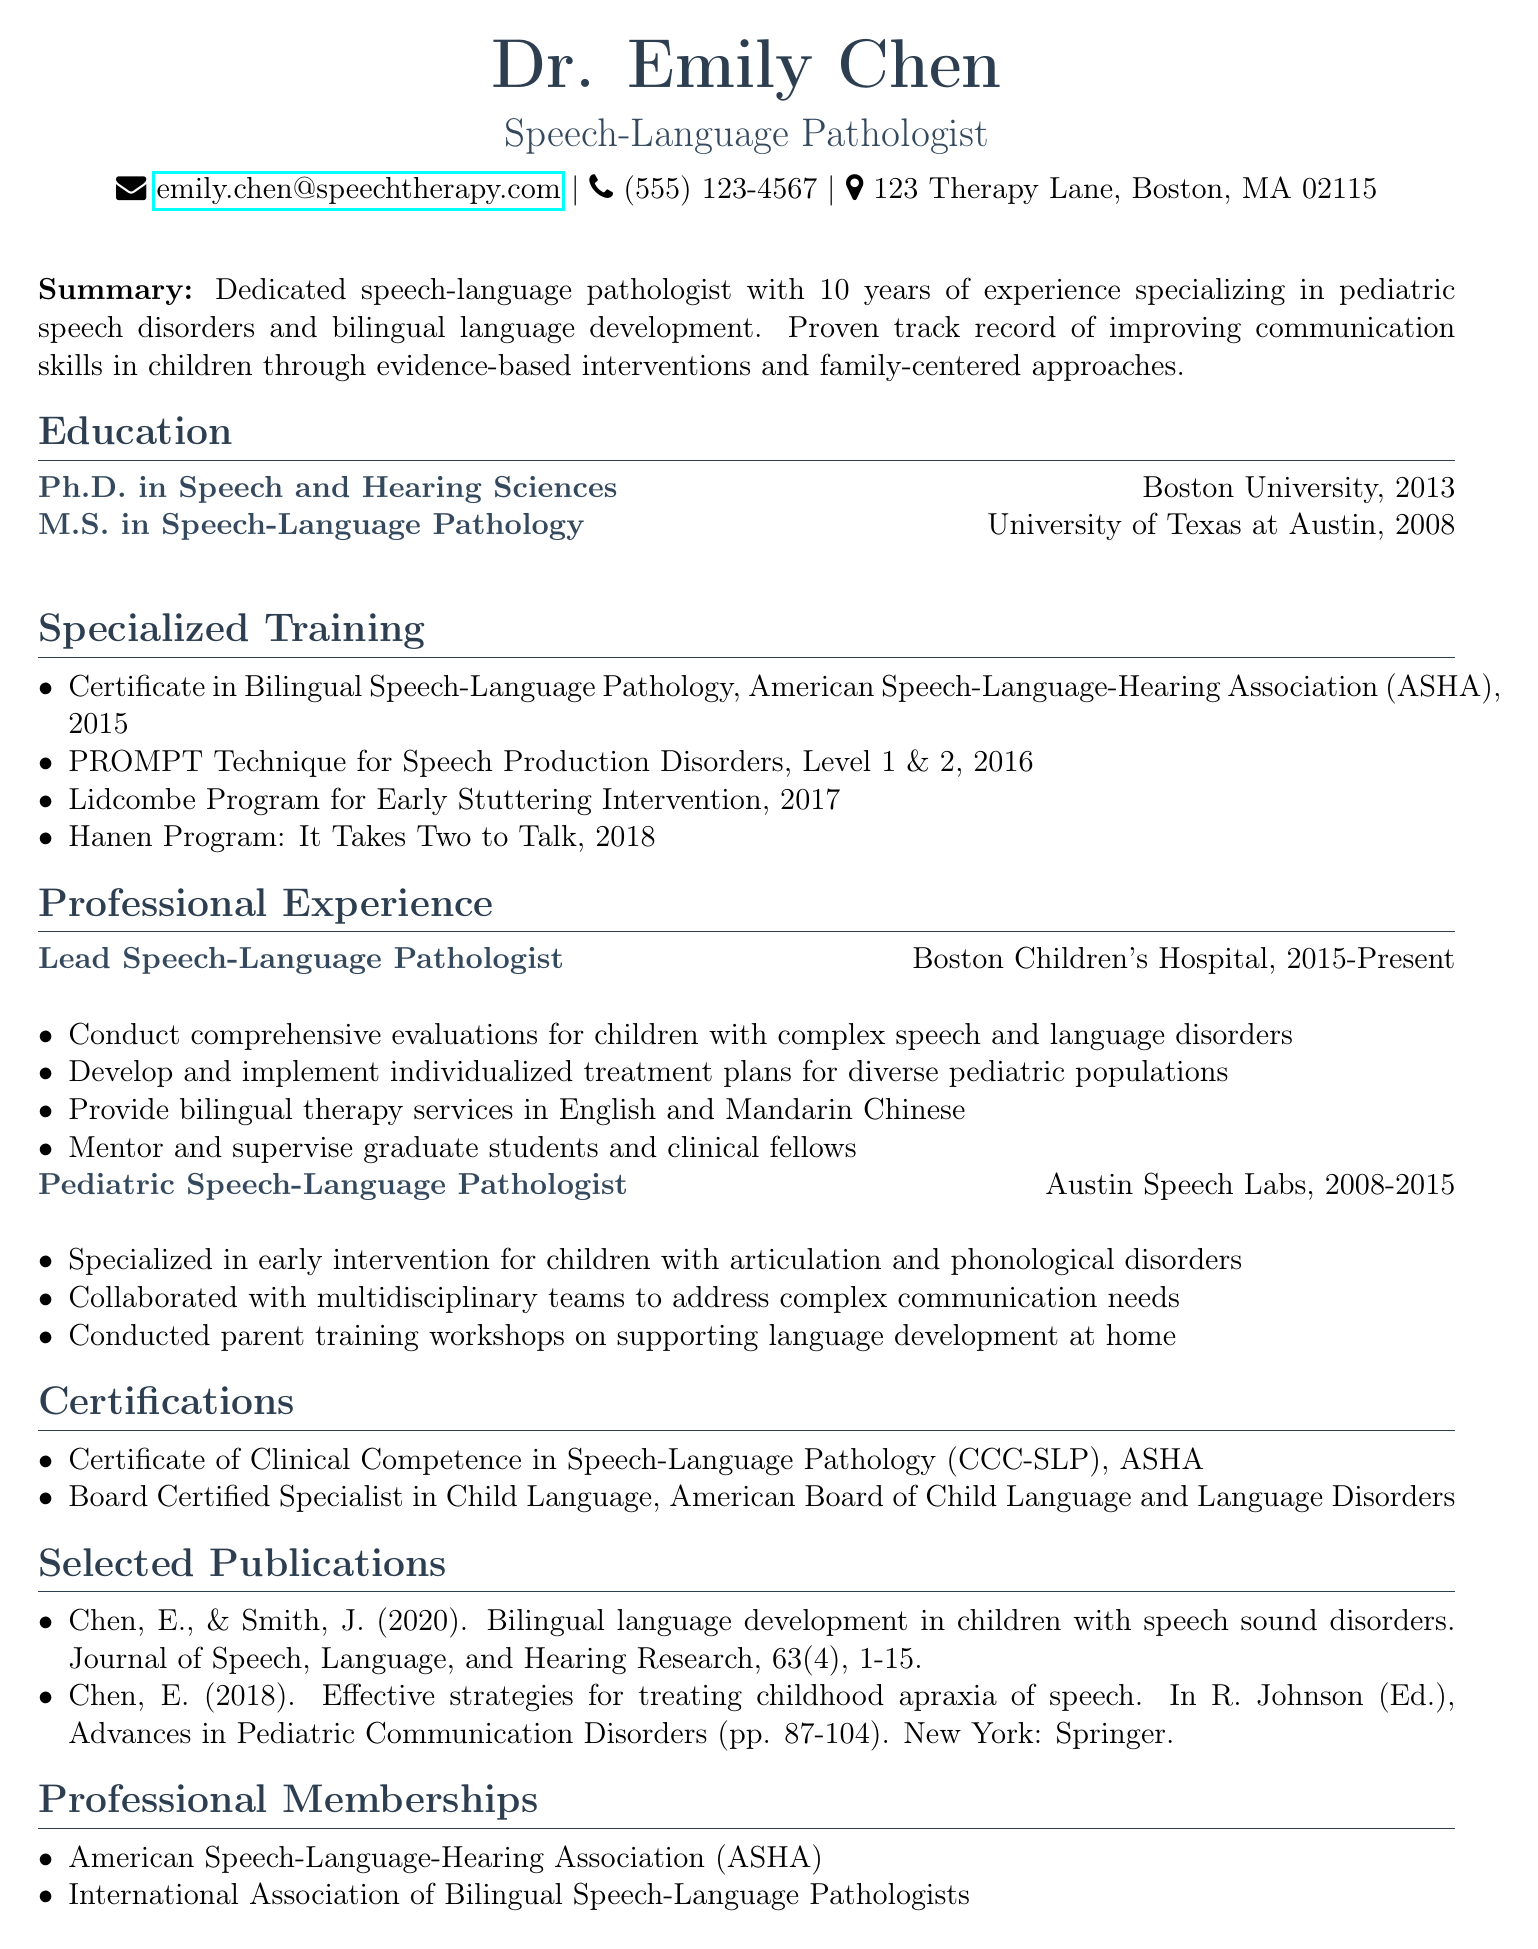What is Dr. Emily Chen's email address? The email address is provided in the personal information section of the CV.
Answer: emily.chen@speechtherapy.com What year did Dr. Emily Chen receive her Ph.D.? The year of the Ph.D. is listed in the education section of the CV.
Answer: 2013 Which program did Dr. Chen complete in 2015? This program is mentioned in the specialized training section, indicating her certification related to bilingual speech-language pathology.
Answer: Certificate in Bilingual Speech-Language Pathology How long has Dr. Chen been working at Boston Children's Hospital? The duration of her position is noted in her professional experience, specifying the start year to the present year.
Answer: 8 years What is the title of one of Dr. Chen's publications? The titles of her publications are listed under the publication section of the CV.
Answer: Bilingual language development in children with speech sound disorders What languages does Dr. Chen provide bilingual therapy in? The languages used for therapy are stated in her current role responsibilities.
Answer: English and Mandarin Chinese What certification does Dr. Chen hold from ASHA? This certification is included in the certifications section of the CV.
Answer: Certificate of Clinical Competence in Speech-Language Pathology (CCC-SLP) Which specific application did Dr. Chen use that relates to early stuttering? The name of the program is detailed in the specialized training section, indicating its focus on early stuttering intervention.
Answer: Lidcombe Program for Early Stuttering Intervention 